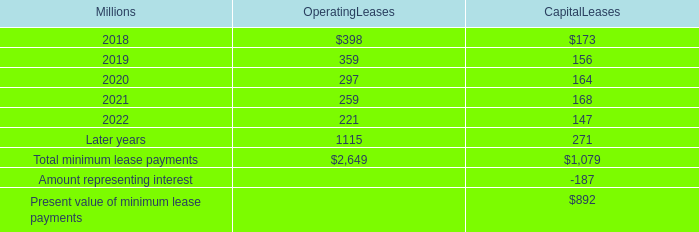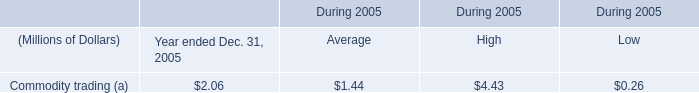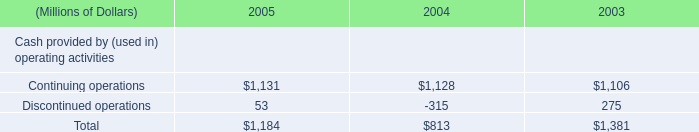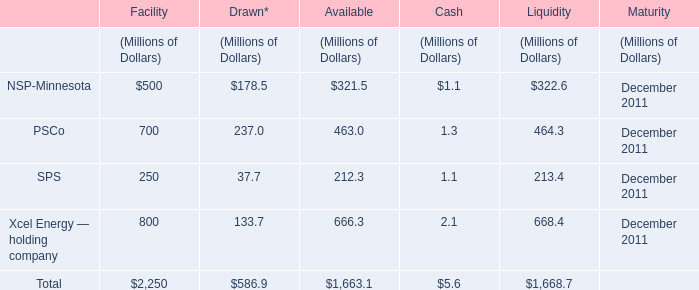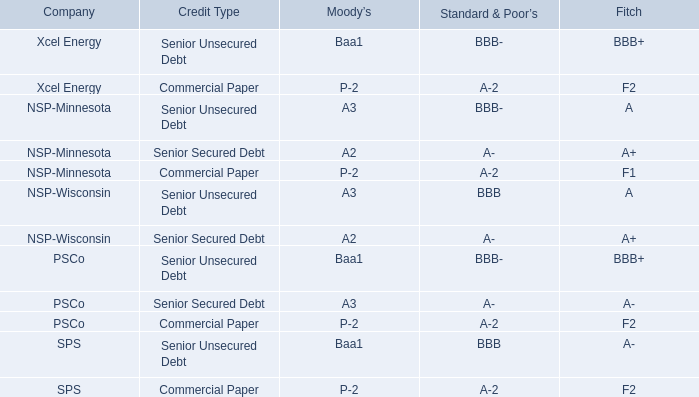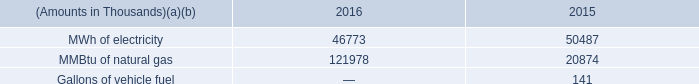What's the 80% of total Facility for Facility? (in Million) 
Computations: (0.8 * 2250)
Answer: 1800.0. 